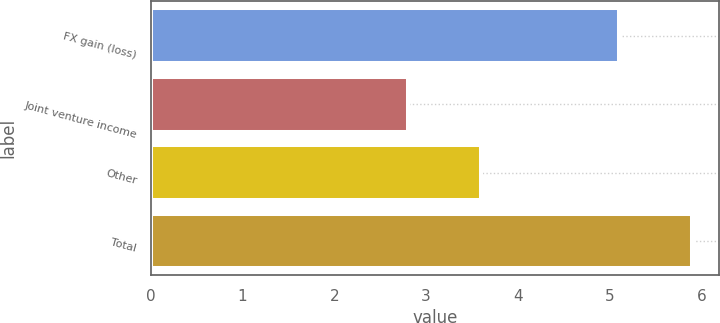<chart> <loc_0><loc_0><loc_500><loc_500><bar_chart><fcel>FX gain (loss)<fcel>Joint venture income<fcel>Other<fcel>Total<nl><fcel>5.1<fcel>2.8<fcel>3.6<fcel>5.9<nl></chart> 